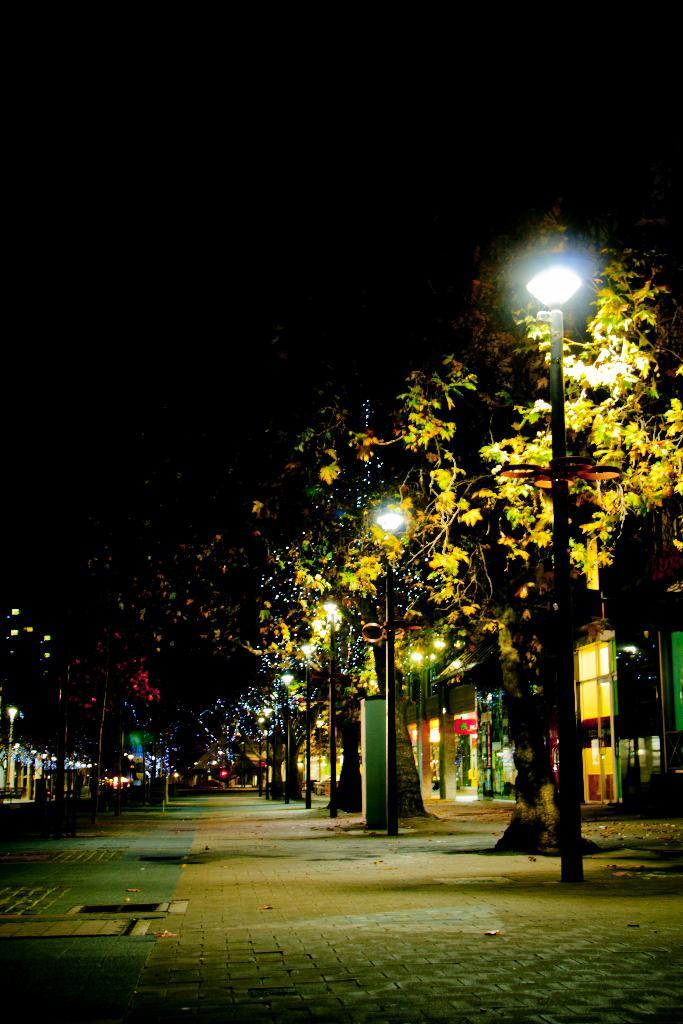What type of vegetation can be seen in the image? There are trees in the image. What structures are present in the image? There are poles and lights in the image. What can be seen in the background of the image? There are buildings and the sky visible in the background of the image. Can you tell me how many goldfish are swimming in the sky in the image? There are no goldfish present in the image, and the sky is not a body of water where goldfish could swim. What type of conversation are the trees having in the image? Trees do not have the ability to talk or engage in conversation, so there is no conversation between the trees in the image. 